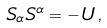Convert formula to latex. <formula><loc_0><loc_0><loc_500><loc_500>S _ { \alpha } S ^ { \alpha } = - \, U \, ,</formula> 